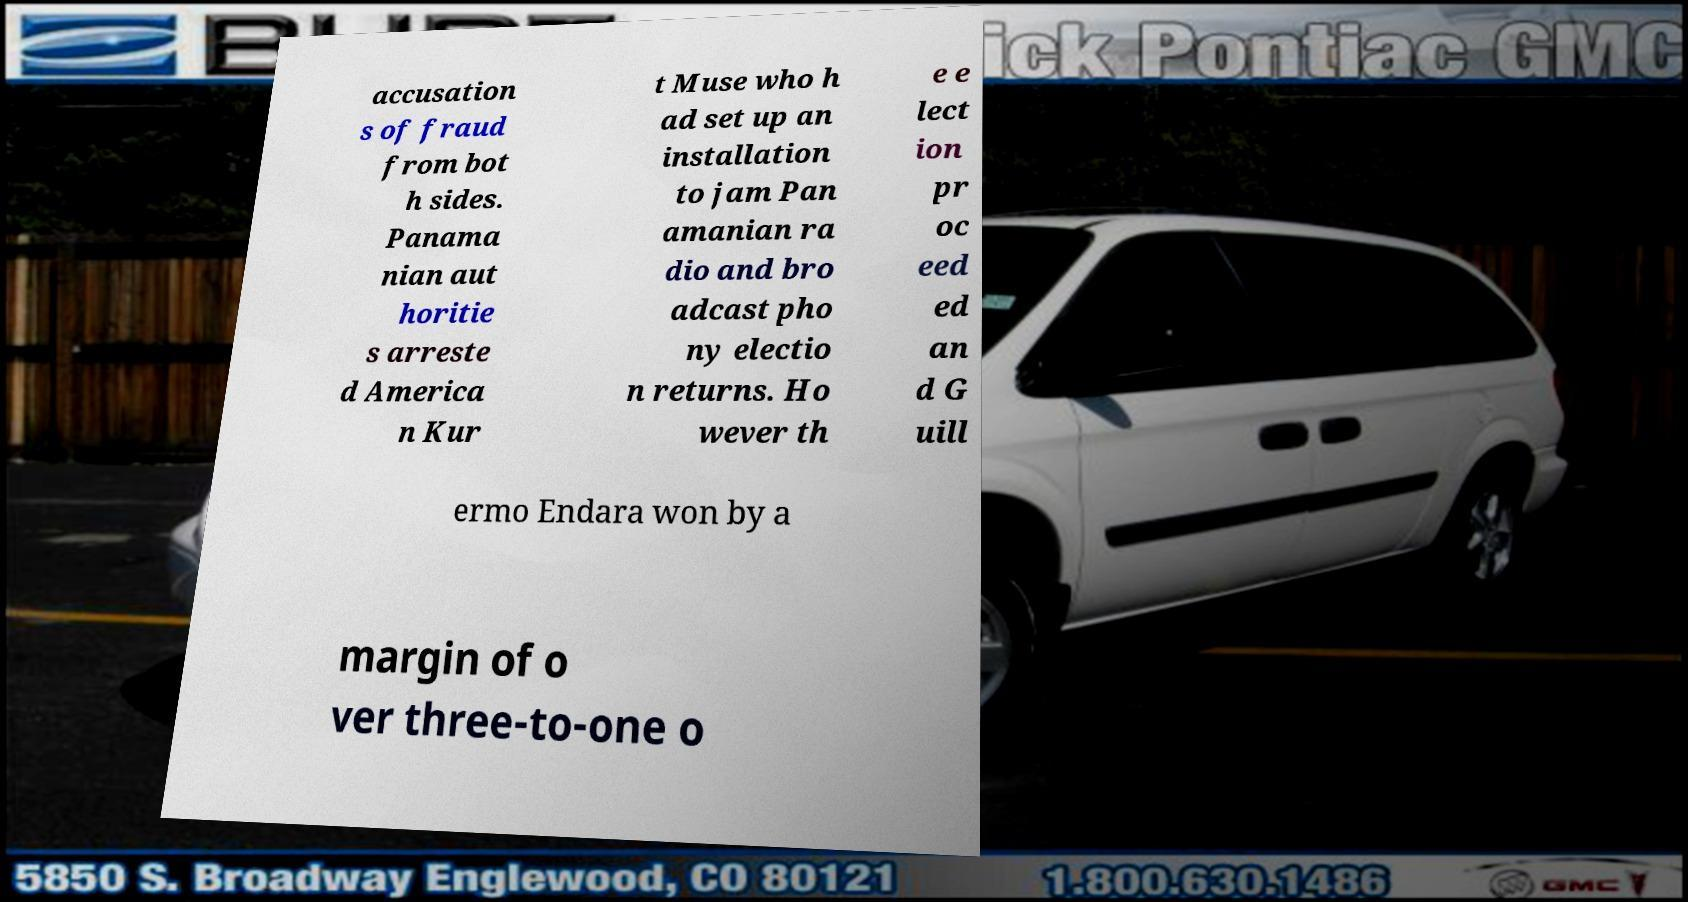Can you read and provide the text displayed in the image?This photo seems to have some interesting text. Can you extract and type it out for me? accusation s of fraud from bot h sides. Panama nian aut horitie s arreste d America n Kur t Muse who h ad set up an installation to jam Pan amanian ra dio and bro adcast pho ny electio n returns. Ho wever th e e lect ion pr oc eed ed an d G uill ermo Endara won by a margin of o ver three-to-one o 